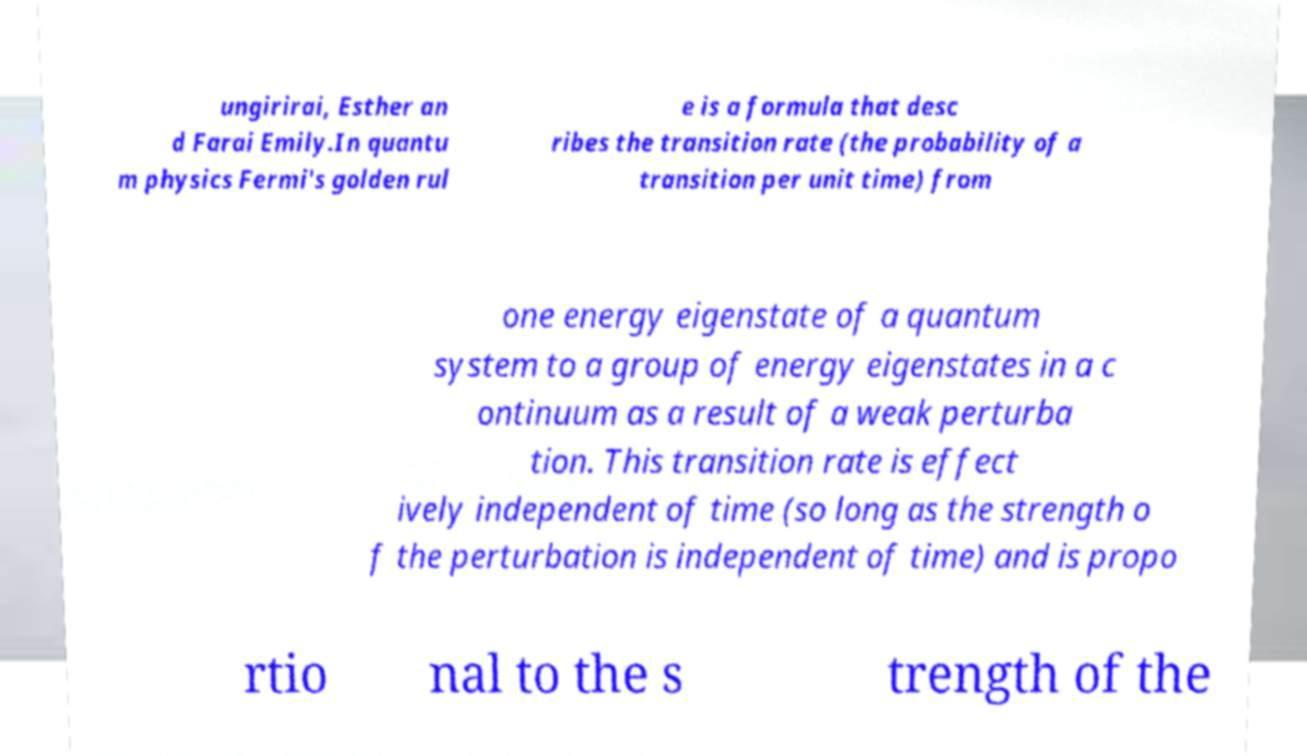What messages or text are displayed in this image? I need them in a readable, typed format. ungirirai, Esther an d Farai Emily.In quantu m physics Fermi's golden rul e is a formula that desc ribes the transition rate (the probability of a transition per unit time) from one energy eigenstate of a quantum system to a group of energy eigenstates in a c ontinuum as a result of a weak perturba tion. This transition rate is effect ively independent of time (so long as the strength o f the perturbation is independent of time) and is propo rtio nal to the s trength of the 